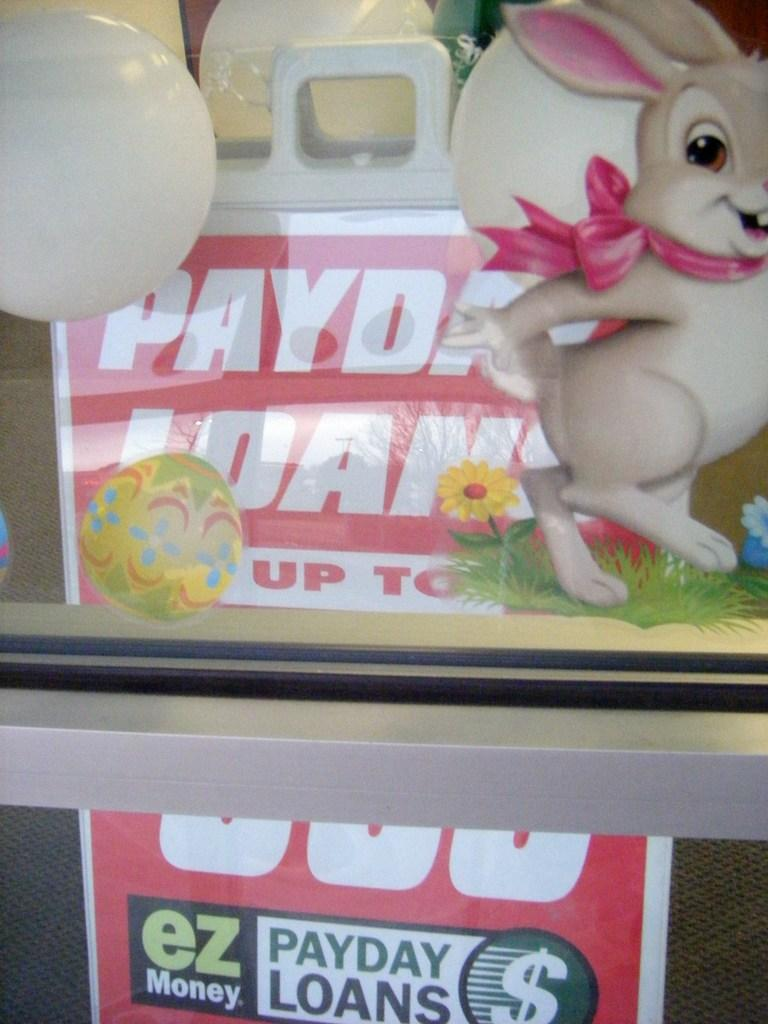<image>
Provide a brief description of the given image. Sign in a store which says EZ money on the bottom. 